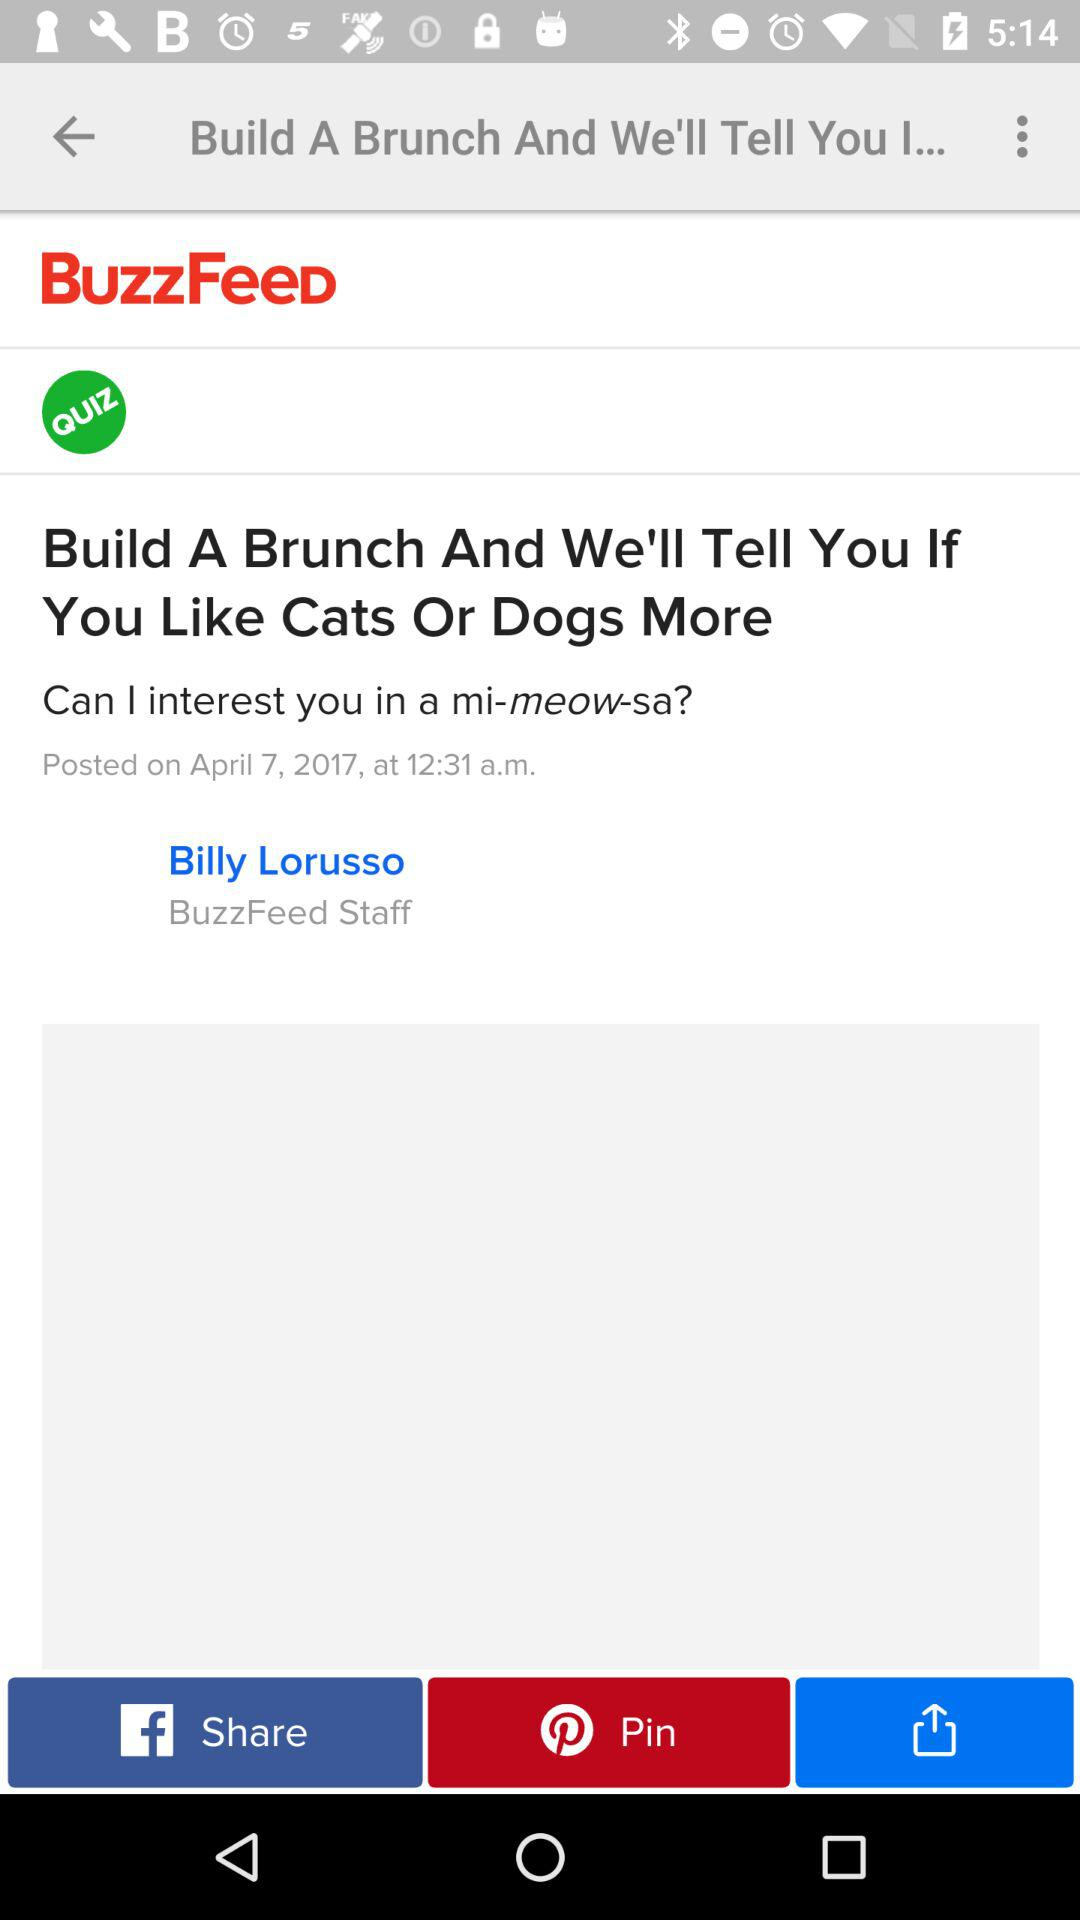Who is the author of the article? The author of the article is Billy Lorusso. 